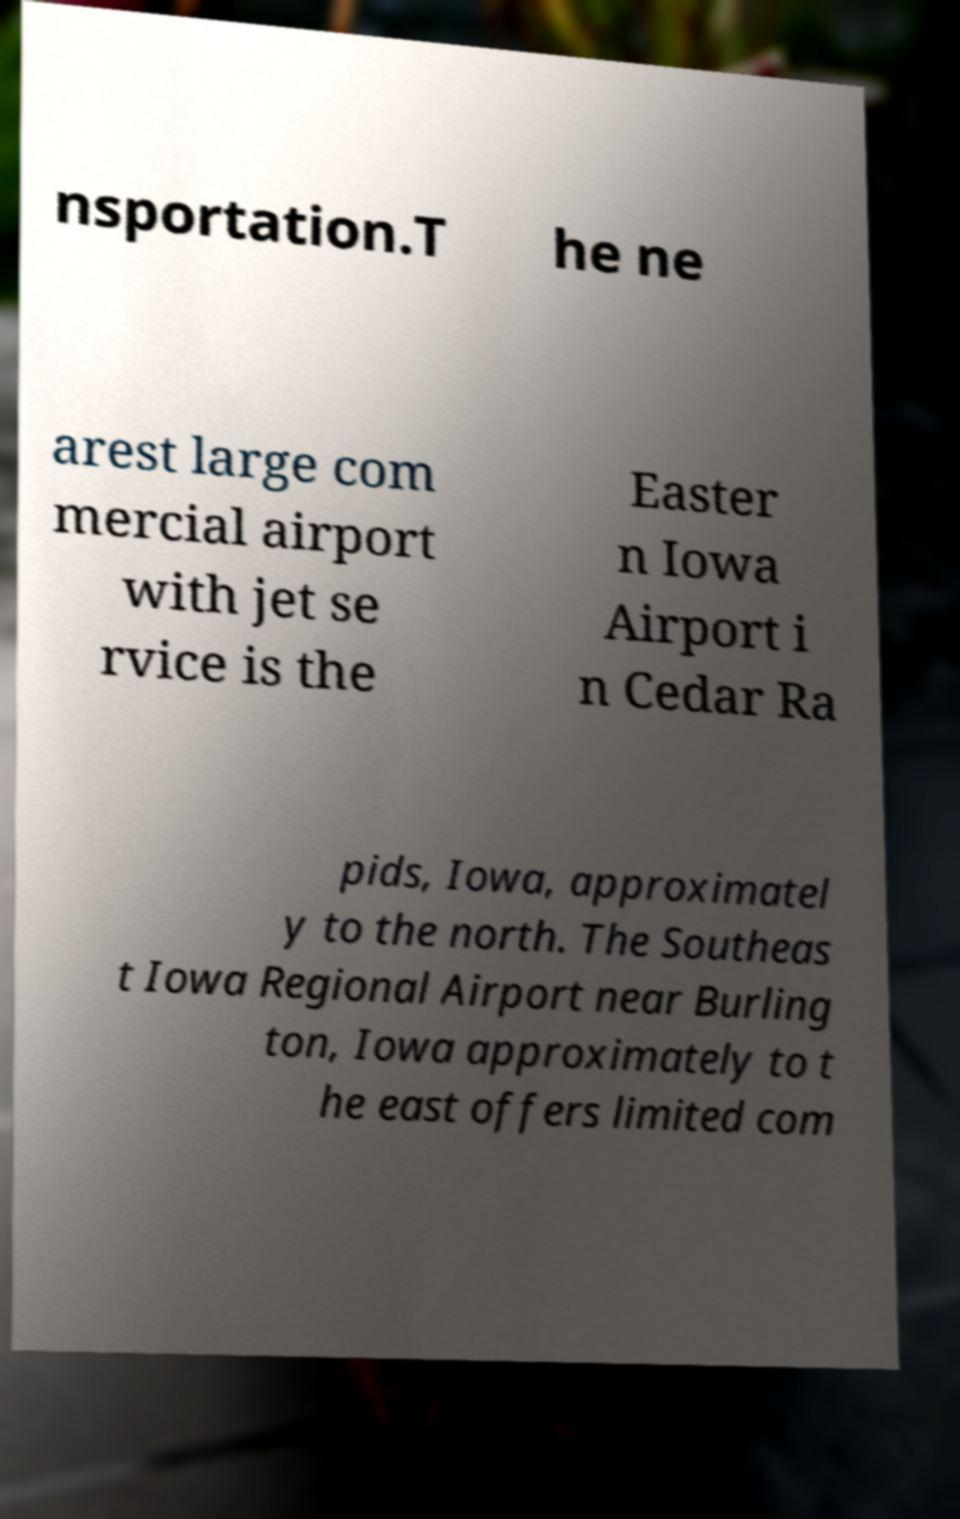For documentation purposes, I need the text within this image transcribed. Could you provide that? nsportation.T he ne arest large com mercial airport with jet se rvice is the Easter n Iowa Airport i n Cedar Ra pids, Iowa, approximatel y to the north. The Southeas t Iowa Regional Airport near Burling ton, Iowa approximately to t he east offers limited com 